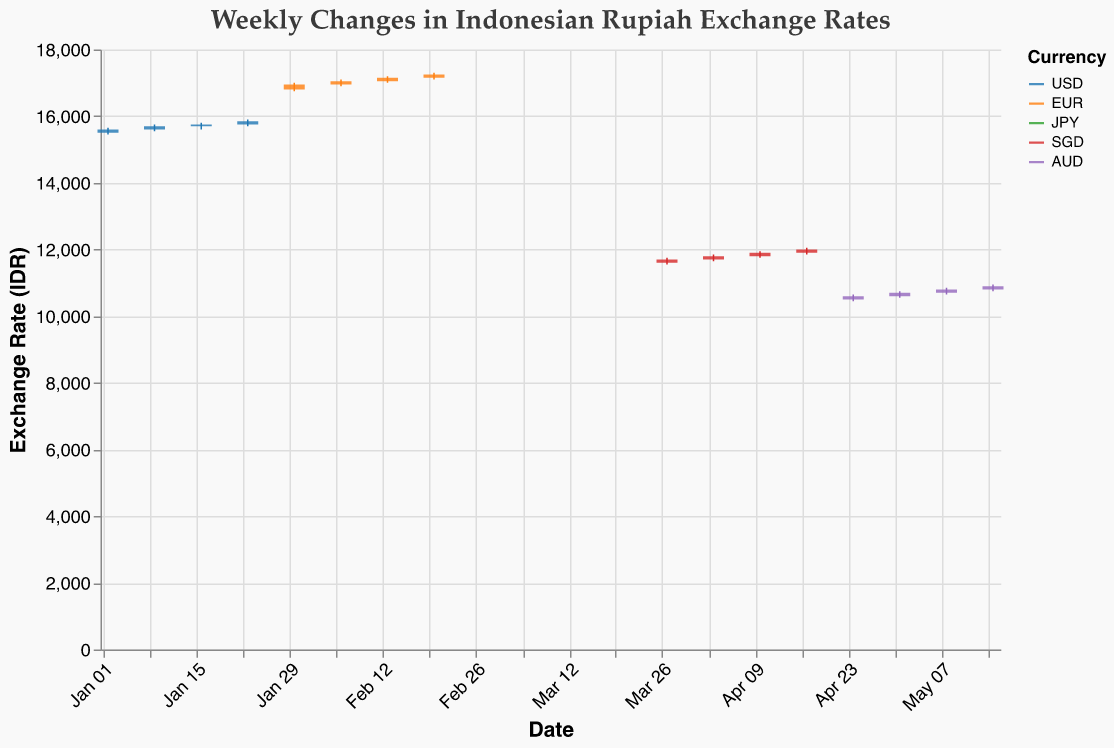What is the title of the chart? The title is located at the top of the chart and usually summarizes what the chart represents. It reads "Weekly Changes in Indonesian Rupiah Exchange Rates" with additional font and color details.
Answer: Weekly Changes in Indonesian Rupiah Exchange Rates Which currency has the highest exchange rate recorded and what is its value? By looking at the 'High' values for each currency, the highest exchange rate recorded is for the Euro (EUR) which peaked during the week of February 20th with a value of 17300 IDR.
Answer: EUR, 17300 IDR What are the opening and closing rates for the Japanese Yen (JPY) during the week of March 20th? To identify the opening and closing rates for the JPY during a specific week, locate the entry corresponding to that date, which shows the Open as 121 and the Close as 122.
Answer: Open: 121, Close: 122 How did the exchange rate of the USD change from the week of January 2nd to January 23rd? For USD, compare the closing rates over the weeks: 15600 (Jan 2), 15700 (Jan 9), 15750 (Jan 16), and 15850 (Jan 23). The trend shows a steady increase each week.
Answer: Increased steadily What's the difference between the highest and lowest recorded prices for the Australian Dollar (AUD) across the entire dataset? The highest price for the AUD is 10950 during the week of May 15th, and the lowest price is 10450 during the week of April 24th, resulting in a difference of 500.
Answer: 500 Which week showed the highest volatility (High-Low) for the Singapore Dollar (SGD)? Volatility is measured by the difference between High and Low values. For the SGD: Mar 27 (200), Apr 3 (200), Apr 10 (200), Apr 17 (200). Hence, all weeks show a consistent volatility of 200.
Answer: All weeks (same volatility) Is there a week where the closing rate for the EUR is higher than the opening rate for the following week? Inspect the closing rate of one week and the opening rate of the next week for EUR: Jan 30-Feb 6 (16950 < 16950), Feb 6-13 (17050 < 17050). None of the closing rates are higher.
Answer: No During which week does the JPY show an upward closing trend throughout the month? To determine if JPY consistently closes higher each week, look at March data: Feb 27 (Close 119), Mar 6 (Close 120), Mar 13 (Close 121), Mar 20 (Close 122). The trend is upward.
Answer: Each week in March 